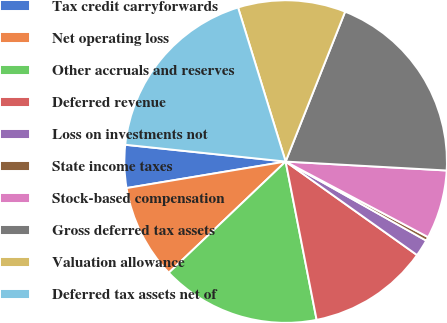<chart> <loc_0><loc_0><loc_500><loc_500><pie_chart><fcel>Tax credit carryforwards<fcel>Net operating loss<fcel>Other accruals and reserves<fcel>Deferred revenue<fcel>Loss on investments not<fcel>State income taxes<fcel>Stock-based compensation<fcel>Gross deferred tax assets<fcel>Valuation allowance<fcel>Deferred tax assets net of<nl><fcel>4.29%<fcel>9.48%<fcel>15.97%<fcel>12.08%<fcel>1.69%<fcel>0.39%<fcel>6.88%<fcel>19.87%<fcel>10.78%<fcel>18.57%<nl></chart> 